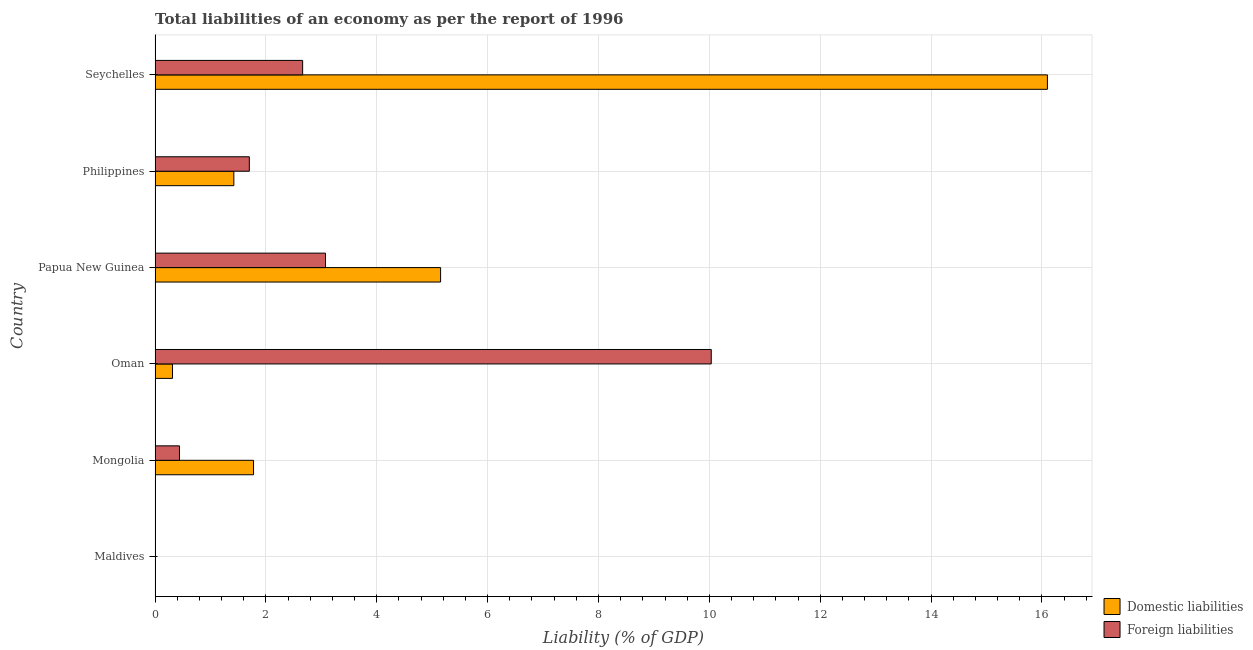How many different coloured bars are there?
Give a very brief answer. 2. Are the number of bars per tick equal to the number of legend labels?
Keep it short and to the point. No. Are the number of bars on each tick of the Y-axis equal?
Keep it short and to the point. No. What is the incurrence of domestic liabilities in Philippines?
Provide a short and direct response. 1.42. Across all countries, what is the maximum incurrence of foreign liabilities?
Your answer should be compact. 10.03. In which country was the incurrence of foreign liabilities maximum?
Make the answer very short. Oman. What is the total incurrence of foreign liabilities in the graph?
Your response must be concise. 17.91. What is the difference between the incurrence of foreign liabilities in Mongolia and that in Papua New Guinea?
Keep it short and to the point. -2.63. What is the difference between the incurrence of foreign liabilities in Philippines and the incurrence of domestic liabilities in Maldives?
Ensure brevity in your answer.  1.7. What is the average incurrence of domestic liabilities per country?
Provide a succinct answer. 4.13. What is the difference between the incurrence of domestic liabilities and incurrence of foreign liabilities in Mongolia?
Your answer should be compact. 1.34. In how many countries, is the incurrence of foreign liabilities greater than 14 %?
Your answer should be very brief. 0. What is the ratio of the incurrence of domestic liabilities in Papua New Guinea to that in Philippines?
Offer a very short reply. 3.62. What is the difference between the highest and the second highest incurrence of foreign liabilities?
Make the answer very short. 6.96. What is the difference between the highest and the lowest incurrence of domestic liabilities?
Provide a short and direct response. 16.1. In how many countries, is the incurrence of foreign liabilities greater than the average incurrence of foreign liabilities taken over all countries?
Give a very brief answer. 2. Is the sum of the incurrence of foreign liabilities in Mongolia and Papua New Guinea greater than the maximum incurrence of domestic liabilities across all countries?
Make the answer very short. No. How many bars are there?
Make the answer very short. 10. How many countries are there in the graph?
Give a very brief answer. 6. What is the difference between two consecutive major ticks on the X-axis?
Make the answer very short. 2. Are the values on the major ticks of X-axis written in scientific E-notation?
Ensure brevity in your answer.  No. Does the graph contain grids?
Provide a short and direct response. Yes. How many legend labels are there?
Ensure brevity in your answer.  2. What is the title of the graph?
Provide a succinct answer. Total liabilities of an economy as per the report of 1996. What is the label or title of the X-axis?
Keep it short and to the point. Liability (% of GDP). What is the label or title of the Y-axis?
Keep it short and to the point. Country. What is the Liability (% of GDP) of Foreign liabilities in Maldives?
Keep it short and to the point. 0. What is the Liability (% of GDP) in Domestic liabilities in Mongolia?
Provide a short and direct response. 1.78. What is the Liability (% of GDP) in Foreign liabilities in Mongolia?
Your response must be concise. 0.44. What is the Liability (% of GDP) in Domestic liabilities in Oman?
Offer a terse response. 0.31. What is the Liability (% of GDP) of Foreign liabilities in Oman?
Provide a succinct answer. 10.03. What is the Liability (% of GDP) of Domestic liabilities in Papua New Guinea?
Provide a short and direct response. 5.15. What is the Liability (% of GDP) in Foreign liabilities in Papua New Guinea?
Offer a very short reply. 3.07. What is the Liability (% of GDP) of Domestic liabilities in Philippines?
Give a very brief answer. 1.42. What is the Liability (% of GDP) in Foreign liabilities in Philippines?
Keep it short and to the point. 1.7. What is the Liability (% of GDP) in Domestic liabilities in Seychelles?
Provide a succinct answer. 16.1. What is the Liability (% of GDP) of Foreign liabilities in Seychelles?
Provide a short and direct response. 2.66. Across all countries, what is the maximum Liability (% of GDP) in Domestic liabilities?
Give a very brief answer. 16.1. Across all countries, what is the maximum Liability (% of GDP) in Foreign liabilities?
Make the answer very short. 10.03. Across all countries, what is the minimum Liability (% of GDP) in Domestic liabilities?
Your answer should be compact. 0. Across all countries, what is the minimum Liability (% of GDP) of Foreign liabilities?
Offer a very short reply. 0. What is the total Liability (% of GDP) of Domestic liabilities in the graph?
Provide a succinct answer. 24.76. What is the total Liability (% of GDP) in Foreign liabilities in the graph?
Make the answer very short. 17.91. What is the difference between the Liability (% of GDP) in Domestic liabilities in Mongolia and that in Oman?
Keep it short and to the point. 1.46. What is the difference between the Liability (% of GDP) of Foreign liabilities in Mongolia and that in Oman?
Give a very brief answer. -9.59. What is the difference between the Liability (% of GDP) in Domestic liabilities in Mongolia and that in Papua New Guinea?
Ensure brevity in your answer.  -3.37. What is the difference between the Liability (% of GDP) in Foreign liabilities in Mongolia and that in Papua New Guinea?
Offer a terse response. -2.63. What is the difference between the Liability (% of GDP) of Domestic liabilities in Mongolia and that in Philippines?
Keep it short and to the point. 0.36. What is the difference between the Liability (% of GDP) of Foreign liabilities in Mongolia and that in Philippines?
Your response must be concise. -1.26. What is the difference between the Liability (% of GDP) of Domestic liabilities in Mongolia and that in Seychelles?
Offer a terse response. -14.32. What is the difference between the Liability (% of GDP) of Foreign liabilities in Mongolia and that in Seychelles?
Give a very brief answer. -2.22. What is the difference between the Liability (% of GDP) in Domestic liabilities in Oman and that in Papua New Guinea?
Keep it short and to the point. -4.84. What is the difference between the Liability (% of GDP) in Foreign liabilities in Oman and that in Papua New Guinea?
Your response must be concise. 6.96. What is the difference between the Liability (% of GDP) of Domestic liabilities in Oman and that in Philippines?
Give a very brief answer. -1.11. What is the difference between the Liability (% of GDP) in Foreign liabilities in Oman and that in Philippines?
Offer a very short reply. 8.33. What is the difference between the Liability (% of GDP) of Domestic liabilities in Oman and that in Seychelles?
Offer a terse response. -15.78. What is the difference between the Liability (% of GDP) in Foreign liabilities in Oman and that in Seychelles?
Offer a very short reply. 7.37. What is the difference between the Liability (% of GDP) of Domestic liabilities in Papua New Guinea and that in Philippines?
Provide a succinct answer. 3.73. What is the difference between the Liability (% of GDP) of Foreign liabilities in Papua New Guinea and that in Philippines?
Offer a terse response. 1.37. What is the difference between the Liability (% of GDP) of Domestic liabilities in Papua New Guinea and that in Seychelles?
Make the answer very short. -10.95. What is the difference between the Liability (% of GDP) of Foreign liabilities in Papua New Guinea and that in Seychelles?
Offer a very short reply. 0.41. What is the difference between the Liability (% of GDP) of Domestic liabilities in Philippines and that in Seychelles?
Make the answer very short. -14.68. What is the difference between the Liability (% of GDP) of Foreign liabilities in Philippines and that in Seychelles?
Keep it short and to the point. -0.96. What is the difference between the Liability (% of GDP) of Domestic liabilities in Mongolia and the Liability (% of GDP) of Foreign liabilities in Oman?
Offer a terse response. -8.26. What is the difference between the Liability (% of GDP) in Domestic liabilities in Mongolia and the Liability (% of GDP) in Foreign liabilities in Papua New Guinea?
Offer a very short reply. -1.3. What is the difference between the Liability (% of GDP) in Domestic liabilities in Mongolia and the Liability (% of GDP) in Foreign liabilities in Philippines?
Provide a succinct answer. 0.08. What is the difference between the Liability (% of GDP) in Domestic liabilities in Mongolia and the Liability (% of GDP) in Foreign liabilities in Seychelles?
Your answer should be compact. -0.89. What is the difference between the Liability (% of GDP) in Domestic liabilities in Oman and the Liability (% of GDP) in Foreign liabilities in Papua New Guinea?
Offer a terse response. -2.76. What is the difference between the Liability (% of GDP) in Domestic liabilities in Oman and the Liability (% of GDP) in Foreign liabilities in Philippines?
Make the answer very short. -1.39. What is the difference between the Liability (% of GDP) of Domestic liabilities in Oman and the Liability (% of GDP) of Foreign liabilities in Seychelles?
Keep it short and to the point. -2.35. What is the difference between the Liability (% of GDP) in Domestic liabilities in Papua New Guinea and the Liability (% of GDP) in Foreign liabilities in Philippines?
Your response must be concise. 3.45. What is the difference between the Liability (% of GDP) in Domestic liabilities in Papua New Guinea and the Liability (% of GDP) in Foreign liabilities in Seychelles?
Ensure brevity in your answer.  2.49. What is the difference between the Liability (% of GDP) of Domestic liabilities in Philippines and the Liability (% of GDP) of Foreign liabilities in Seychelles?
Provide a short and direct response. -1.24. What is the average Liability (% of GDP) of Domestic liabilities per country?
Provide a short and direct response. 4.13. What is the average Liability (% of GDP) of Foreign liabilities per country?
Offer a very short reply. 2.99. What is the difference between the Liability (% of GDP) in Domestic liabilities and Liability (% of GDP) in Foreign liabilities in Mongolia?
Offer a terse response. 1.34. What is the difference between the Liability (% of GDP) of Domestic liabilities and Liability (% of GDP) of Foreign liabilities in Oman?
Provide a short and direct response. -9.72. What is the difference between the Liability (% of GDP) in Domestic liabilities and Liability (% of GDP) in Foreign liabilities in Papua New Guinea?
Your answer should be compact. 2.08. What is the difference between the Liability (% of GDP) in Domestic liabilities and Liability (% of GDP) in Foreign liabilities in Philippines?
Keep it short and to the point. -0.28. What is the difference between the Liability (% of GDP) of Domestic liabilities and Liability (% of GDP) of Foreign liabilities in Seychelles?
Provide a succinct answer. 13.44. What is the ratio of the Liability (% of GDP) of Domestic liabilities in Mongolia to that in Oman?
Make the answer very short. 5.64. What is the ratio of the Liability (% of GDP) of Foreign liabilities in Mongolia to that in Oman?
Give a very brief answer. 0.04. What is the ratio of the Liability (% of GDP) in Domestic liabilities in Mongolia to that in Papua New Guinea?
Provide a succinct answer. 0.34. What is the ratio of the Liability (% of GDP) of Foreign liabilities in Mongolia to that in Papua New Guinea?
Give a very brief answer. 0.14. What is the ratio of the Liability (% of GDP) of Domestic liabilities in Mongolia to that in Philippines?
Your answer should be compact. 1.25. What is the ratio of the Liability (% of GDP) in Foreign liabilities in Mongolia to that in Philippines?
Provide a short and direct response. 0.26. What is the ratio of the Liability (% of GDP) of Domestic liabilities in Mongolia to that in Seychelles?
Keep it short and to the point. 0.11. What is the ratio of the Liability (% of GDP) of Foreign liabilities in Mongolia to that in Seychelles?
Your answer should be very brief. 0.17. What is the ratio of the Liability (% of GDP) in Domestic liabilities in Oman to that in Papua New Guinea?
Offer a terse response. 0.06. What is the ratio of the Liability (% of GDP) of Foreign liabilities in Oman to that in Papua New Guinea?
Offer a terse response. 3.26. What is the ratio of the Liability (% of GDP) of Domestic liabilities in Oman to that in Philippines?
Your answer should be very brief. 0.22. What is the ratio of the Liability (% of GDP) in Foreign liabilities in Oman to that in Philippines?
Provide a short and direct response. 5.9. What is the ratio of the Liability (% of GDP) in Domestic liabilities in Oman to that in Seychelles?
Provide a short and direct response. 0.02. What is the ratio of the Liability (% of GDP) of Foreign liabilities in Oman to that in Seychelles?
Give a very brief answer. 3.77. What is the ratio of the Liability (% of GDP) in Domestic liabilities in Papua New Guinea to that in Philippines?
Your answer should be very brief. 3.62. What is the ratio of the Liability (% of GDP) of Foreign liabilities in Papua New Guinea to that in Philippines?
Your response must be concise. 1.81. What is the ratio of the Liability (% of GDP) in Domestic liabilities in Papua New Guinea to that in Seychelles?
Your answer should be very brief. 0.32. What is the ratio of the Liability (% of GDP) in Foreign liabilities in Papua New Guinea to that in Seychelles?
Provide a short and direct response. 1.16. What is the ratio of the Liability (% of GDP) in Domestic liabilities in Philippines to that in Seychelles?
Give a very brief answer. 0.09. What is the ratio of the Liability (% of GDP) in Foreign liabilities in Philippines to that in Seychelles?
Your answer should be very brief. 0.64. What is the difference between the highest and the second highest Liability (% of GDP) in Domestic liabilities?
Provide a short and direct response. 10.95. What is the difference between the highest and the second highest Liability (% of GDP) in Foreign liabilities?
Your response must be concise. 6.96. What is the difference between the highest and the lowest Liability (% of GDP) in Domestic liabilities?
Ensure brevity in your answer.  16.1. What is the difference between the highest and the lowest Liability (% of GDP) in Foreign liabilities?
Ensure brevity in your answer.  10.03. 